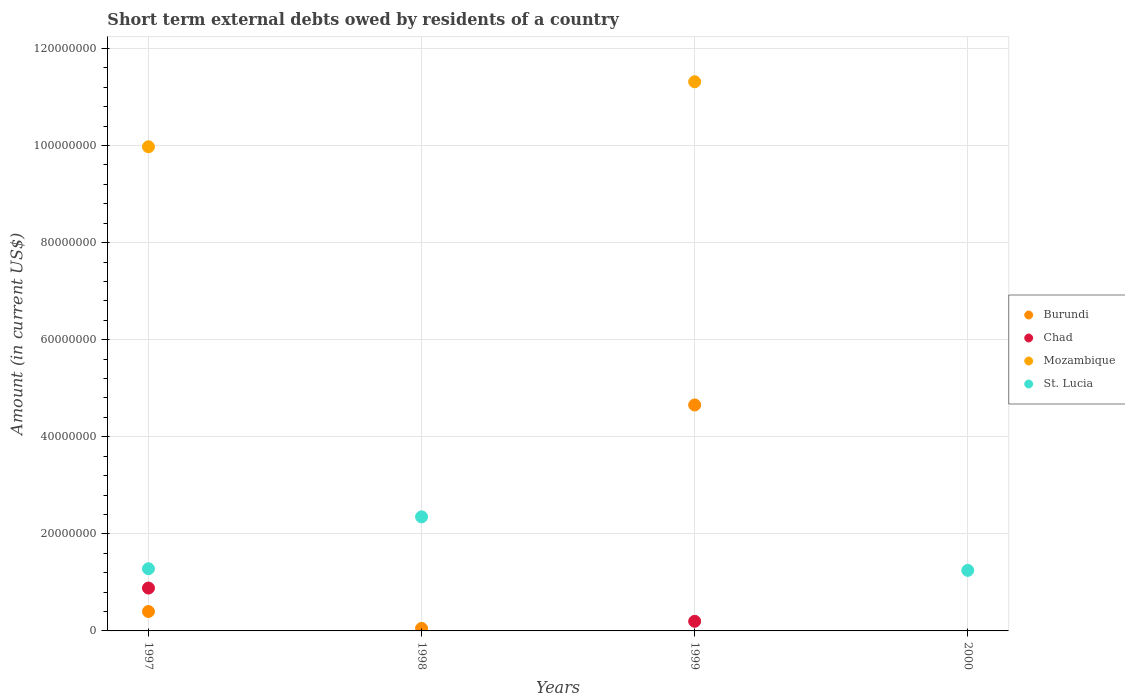Is the number of dotlines equal to the number of legend labels?
Provide a succinct answer. No. What is the amount of short-term external debts owed by residents in St. Lucia in 2000?
Provide a short and direct response. 1.25e+07. Across all years, what is the maximum amount of short-term external debts owed by residents in St. Lucia?
Keep it short and to the point. 2.35e+07. What is the total amount of short-term external debts owed by residents in Burundi in the graph?
Ensure brevity in your answer.  5.11e+07. What is the difference between the amount of short-term external debts owed by residents in St. Lucia in 1997 and that in 2000?
Ensure brevity in your answer.  3.40e+05. What is the difference between the amount of short-term external debts owed by residents in Mozambique in 1997 and the amount of short-term external debts owed by residents in St. Lucia in 1999?
Make the answer very short. 9.97e+07. What is the average amount of short-term external debts owed by residents in Mozambique per year?
Your response must be concise. 5.32e+07. In the year 1997, what is the difference between the amount of short-term external debts owed by residents in Burundi and amount of short-term external debts owed by residents in Chad?
Provide a succinct answer. -4.83e+06. In how many years, is the amount of short-term external debts owed by residents in Chad greater than 80000000 US$?
Provide a short and direct response. 0. What is the ratio of the amount of short-term external debts owed by residents in Mozambique in 1997 to that in 1999?
Provide a succinct answer. 0.88. Is the amount of short-term external debts owed by residents in St. Lucia in 1997 less than that in 2000?
Provide a short and direct response. No. Is the difference between the amount of short-term external debts owed by residents in Burundi in 1997 and 1999 greater than the difference between the amount of short-term external debts owed by residents in Chad in 1997 and 1999?
Make the answer very short. No. What is the difference between the highest and the second highest amount of short-term external debts owed by residents in St. Lucia?
Provide a short and direct response. 1.07e+07. What is the difference between the highest and the lowest amount of short-term external debts owed by residents in St. Lucia?
Ensure brevity in your answer.  2.35e+07. In how many years, is the amount of short-term external debts owed by residents in Chad greater than the average amount of short-term external debts owed by residents in Chad taken over all years?
Ensure brevity in your answer.  1. Does the amount of short-term external debts owed by residents in Chad monotonically increase over the years?
Provide a short and direct response. No. Is the amount of short-term external debts owed by residents in Chad strictly greater than the amount of short-term external debts owed by residents in Mozambique over the years?
Offer a very short reply. No. How many years are there in the graph?
Your answer should be very brief. 4. What is the difference between two consecutive major ticks on the Y-axis?
Offer a terse response. 2.00e+07. Are the values on the major ticks of Y-axis written in scientific E-notation?
Your answer should be compact. No. Does the graph contain any zero values?
Your answer should be compact. Yes. Does the graph contain grids?
Your answer should be very brief. Yes. How many legend labels are there?
Offer a terse response. 4. What is the title of the graph?
Your answer should be compact. Short term external debts owed by residents of a country. What is the label or title of the X-axis?
Your response must be concise. Years. What is the label or title of the Y-axis?
Your response must be concise. Amount (in current US$). What is the Amount (in current US$) of Burundi in 1997?
Provide a succinct answer. 4.00e+06. What is the Amount (in current US$) in Chad in 1997?
Offer a very short reply. 8.83e+06. What is the Amount (in current US$) in Mozambique in 1997?
Provide a succinct answer. 9.97e+07. What is the Amount (in current US$) in St. Lucia in 1997?
Offer a very short reply. 1.28e+07. What is the Amount (in current US$) of Burundi in 1998?
Offer a very short reply. 5.20e+05. What is the Amount (in current US$) in Chad in 1998?
Offer a terse response. 0. What is the Amount (in current US$) in Mozambique in 1998?
Give a very brief answer. 0. What is the Amount (in current US$) of St. Lucia in 1998?
Your response must be concise. 2.35e+07. What is the Amount (in current US$) of Burundi in 1999?
Provide a short and direct response. 4.66e+07. What is the Amount (in current US$) of Chad in 1999?
Make the answer very short. 1.98e+06. What is the Amount (in current US$) of Mozambique in 1999?
Give a very brief answer. 1.13e+08. What is the Amount (in current US$) in St. Lucia in 1999?
Offer a very short reply. 0. What is the Amount (in current US$) of Burundi in 2000?
Provide a succinct answer. 0. What is the Amount (in current US$) in Chad in 2000?
Ensure brevity in your answer.  0. What is the Amount (in current US$) in St. Lucia in 2000?
Provide a succinct answer. 1.25e+07. Across all years, what is the maximum Amount (in current US$) in Burundi?
Keep it short and to the point. 4.66e+07. Across all years, what is the maximum Amount (in current US$) in Chad?
Provide a succinct answer. 8.83e+06. Across all years, what is the maximum Amount (in current US$) in Mozambique?
Keep it short and to the point. 1.13e+08. Across all years, what is the maximum Amount (in current US$) in St. Lucia?
Offer a terse response. 2.35e+07. Across all years, what is the minimum Amount (in current US$) in Mozambique?
Keep it short and to the point. 0. What is the total Amount (in current US$) in Burundi in the graph?
Your response must be concise. 5.11e+07. What is the total Amount (in current US$) of Chad in the graph?
Provide a succinct answer. 1.08e+07. What is the total Amount (in current US$) of Mozambique in the graph?
Provide a short and direct response. 2.13e+08. What is the total Amount (in current US$) of St. Lucia in the graph?
Provide a short and direct response. 4.88e+07. What is the difference between the Amount (in current US$) of Burundi in 1997 and that in 1998?
Keep it short and to the point. 3.48e+06. What is the difference between the Amount (in current US$) in St. Lucia in 1997 and that in 1998?
Keep it short and to the point. -1.07e+07. What is the difference between the Amount (in current US$) in Burundi in 1997 and that in 1999?
Your answer should be very brief. -4.26e+07. What is the difference between the Amount (in current US$) in Chad in 1997 and that in 1999?
Ensure brevity in your answer.  6.85e+06. What is the difference between the Amount (in current US$) in Mozambique in 1997 and that in 1999?
Offer a terse response. -1.34e+07. What is the difference between the Amount (in current US$) in St. Lucia in 1997 and that in 2000?
Make the answer very short. 3.40e+05. What is the difference between the Amount (in current US$) of Burundi in 1998 and that in 1999?
Provide a short and direct response. -4.60e+07. What is the difference between the Amount (in current US$) of St. Lucia in 1998 and that in 2000?
Make the answer very short. 1.10e+07. What is the difference between the Amount (in current US$) of Burundi in 1997 and the Amount (in current US$) of St. Lucia in 1998?
Your answer should be compact. -1.95e+07. What is the difference between the Amount (in current US$) in Chad in 1997 and the Amount (in current US$) in St. Lucia in 1998?
Keep it short and to the point. -1.47e+07. What is the difference between the Amount (in current US$) of Mozambique in 1997 and the Amount (in current US$) of St. Lucia in 1998?
Give a very brief answer. 7.62e+07. What is the difference between the Amount (in current US$) of Burundi in 1997 and the Amount (in current US$) of Chad in 1999?
Provide a short and direct response. 2.02e+06. What is the difference between the Amount (in current US$) of Burundi in 1997 and the Amount (in current US$) of Mozambique in 1999?
Make the answer very short. -1.09e+08. What is the difference between the Amount (in current US$) of Chad in 1997 and the Amount (in current US$) of Mozambique in 1999?
Your answer should be very brief. -1.04e+08. What is the difference between the Amount (in current US$) of Burundi in 1997 and the Amount (in current US$) of St. Lucia in 2000?
Provide a short and direct response. -8.47e+06. What is the difference between the Amount (in current US$) in Chad in 1997 and the Amount (in current US$) in St. Lucia in 2000?
Offer a very short reply. -3.64e+06. What is the difference between the Amount (in current US$) in Mozambique in 1997 and the Amount (in current US$) in St. Lucia in 2000?
Your response must be concise. 8.73e+07. What is the difference between the Amount (in current US$) in Burundi in 1998 and the Amount (in current US$) in Chad in 1999?
Offer a terse response. -1.46e+06. What is the difference between the Amount (in current US$) in Burundi in 1998 and the Amount (in current US$) in Mozambique in 1999?
Give a very brief answer. -1.13e+08. What is the difference between the Amount (in current US$) of Burundi in 1998 and the Amount (in current US$) of St. Lucia in 2000?
Keep it short and to the point. -1.20e+07. What is the difference between the Amount (in current US$) of Burundi in 1999 and the Amount (in current US$) of St. Lucia in 2000?
Offer a very short reply. 3.41e+07. What is the difference between the Amount (in current US$) of Chad in 1999 and the Amount (in current US$) of St. Lucia in 2000?
Your response must be concise. -1.05e+07. What is the difference between the Amount (in current US$) in Mozambique in 1999 and the Amount (in current US$) in St. Lucia in 2000?
Give a very brief answer. 1.01e+08. What is the average Amount (in current US$) in Burundi per year?
Keep it short and to the point. 1.28e+07. What is the average Amount (in current US$) in Chad per year?
Offer a very short reply. 2.70e+06. What is the average Amount (in current US$) of Mozambique per year?
Make the answer very short. 5.32e+07. What is the average Amount (in current US$) of St. Lucia per year?
Your answer should be very brief. 1.22e+07. In the year 1997, what is the difference between the Amount (in current US$) of Burundi and Amount (in current US$) of Chad?
Give a very brief answer. -4.83e+06. In the year 1997, what is the difference between the Amount (in current US$) in Burundi and Amount (in current US$) in Mozambique?
Make the answer very short. -9.57e+07. In the year 1997, what is the difference between the Amount (in current US$) in Burundi and Amount (in current US$) in St. Lucia?
Offer a terse response. -8.81e+06. In the year 1997, what is the difference between the Amount (in current US$) of Chad and Amount (in current US$) of Mozambique?
Provide a succinct answer. -9.09e+07. In the year 1997, what is the difference between the Amount (in current US$) in Chad and Amount (in current US$) in St. Lucia?
Offer a terse response. -3.98e+06. In the year 1997, what is the difference between the Amount (in current US$) of Mozambique and Amount (in current US$) of St. Lucia?
Your response must be concise. 8.69e+07. In the year 1998, what is the difference between the Amount (in current US$) in Burundi and Amount (in current US$) in St. Lucia?
Your response must be concise. -2.30e+07. In the year 1999, what is the difference between the Amount (in current US$) in Burundi and Amount (in current US$) in Chad?
Make the answer very short. 4.46e+07. In the year 1999, what is the difference between the Amount (in current US$) of Burundi and Amount (in current US$) of Mozambique?
Keep it short and to the point. -6.66e+07. In the year 1999, what is the difference between the Amount (in current US$) in Chad and Amount (in current US$) in Mozambique?
Ensure brevity in your answer.  -1.11e+08. What is the ratio of the Amount (in current US$) in Burundi in 1997 to that in 1998?
Give a very brief answer. 7.69. What is the ratio of the Amount (in current US$) in St. Lucia in 1997 to that in 1998?
Your answer should be compact. 0.55. What is the ratio of the Amount (in current US$) in Burundi in 1997 to that in 1999?
Keep it short and to the point. 0.09. What is the ratio of the Amount (in current US$) of Chad in 1997 to that in 1999?
Offer a very short reply. 4.46. What is the ratio of the Amount (in current US$) of Mozambique in 1997 to that in 1999?
Your answer should be compact. 0.88. What is the ratio of the Amount (in current US$) in St. Lucia in 1997 to that in 2000?
Provide a short and direct response. 1.03. What is the ratio of the Amount (in current US$) of Burundi in 1998 to that in 1999?
Provide a succinct answer. 0.01. What is the ratio of the Amount (in current US$) of St. Lucia in 1998 to that in 2000?
Keep it short and to the point. 1.88. What is the difference between the highest and the second highest Amount (in current US$) of Burundi?
Ensure brevity in your answer.  4.26e+07. What is the difference between the highest and the second highest Amount (in current US$) in St. Lucia?
Ensure brevity in your answer.  1.07e+07. What is the difference between the highest and the lowest Amount (in current US$) in Burundi?
Your answer should be compact. 4.66e+07. What is the difference between the highest and the lowest Amount (in current US$) in Chad?
Provide a short and direct response. 8.83e+06. What is the difference between the highest and the lowest Amount (in current US$) in Mozambique?
Keep it short and to the point. 1.13e+08. What is the difference between the highest and the lowest Amount (in current US$) of St. Lucia?
Make the answer very short. 2.35e+07. 